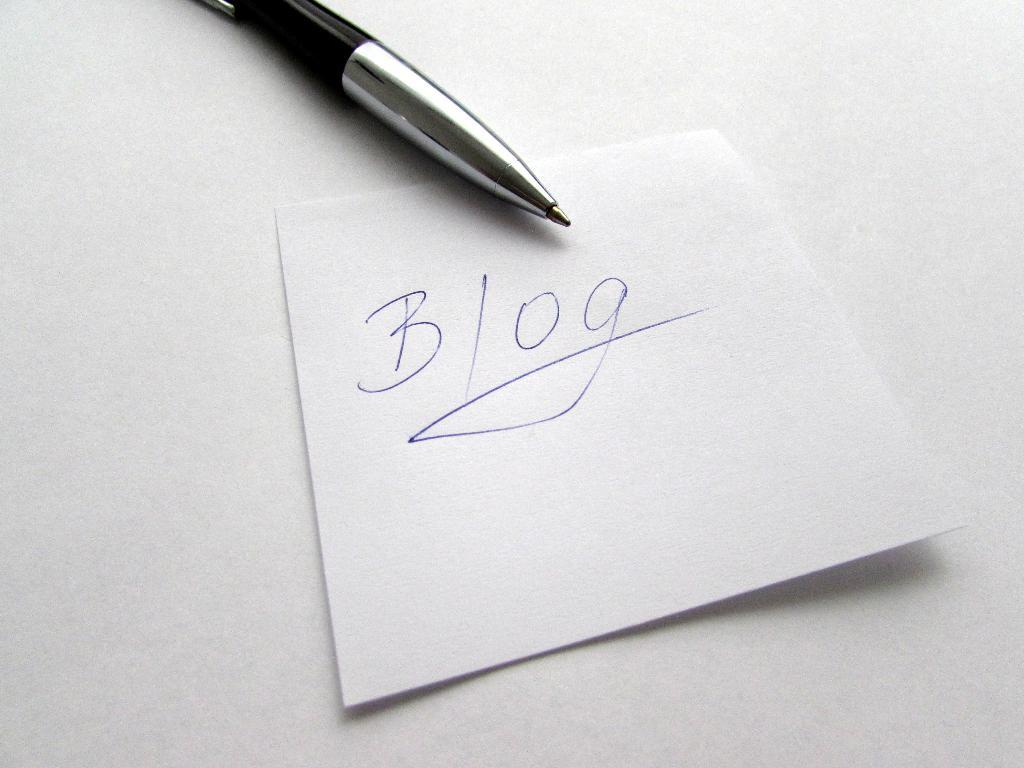What is the primary object in the image? There is a white paper in the image. What can be seen on the white paper? Something is written on the paper with blue color. What is located near the white paper? There is a pen on the white surface. Can you tell me how many kitties are playing with a rock in the image? There are no kitties or rocks present in the image; it features a white paper with writing and a pen. What type of rabbit can be seen interacting with the pen in the image? There is no rabbit present in the image; only the white paper, writing, and pen are visible. 